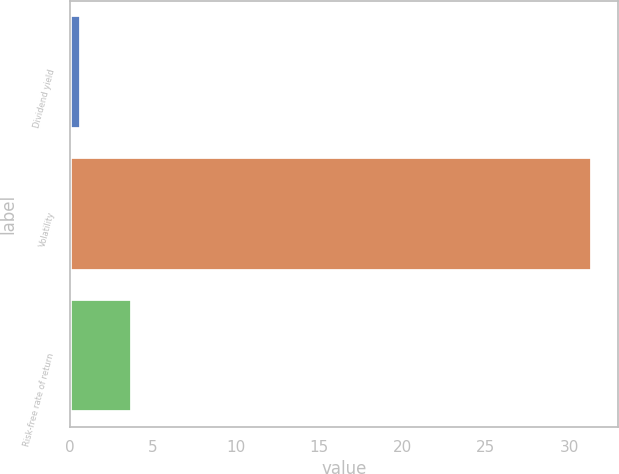Convert chart to OTSL. <chart><loc_0><loc_0><loc_500><loc_500><bar_chart><fcel>Dividend yield<fcel>Volatility<fcel>Risk-free rate of return<nl><fcel>0.69<fcel>31.37<fcel>3.76<nl></chart> 